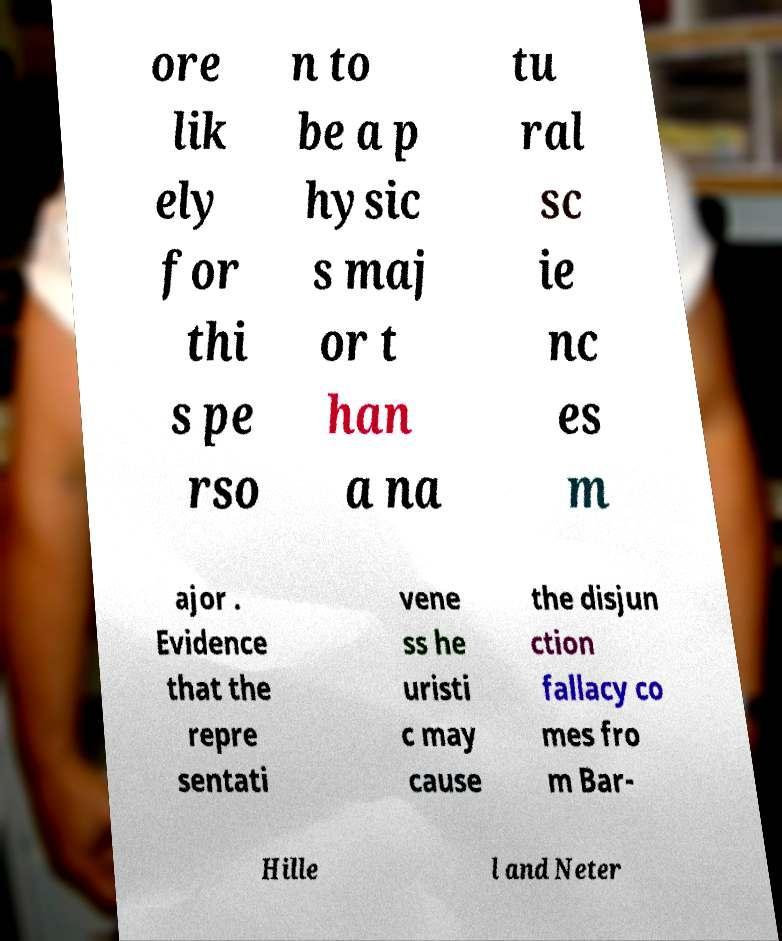Please identify and transcribe the text found in this image. ore lik ely for thi s pe rso n to be a p hysic s maj or t han a na tu ral sc ie nc es m ajor . Evidence that the repre sentati vene ss he uristi c may cause the disjun ction fallacy co mes fro m Bar- Hille l and Neter 